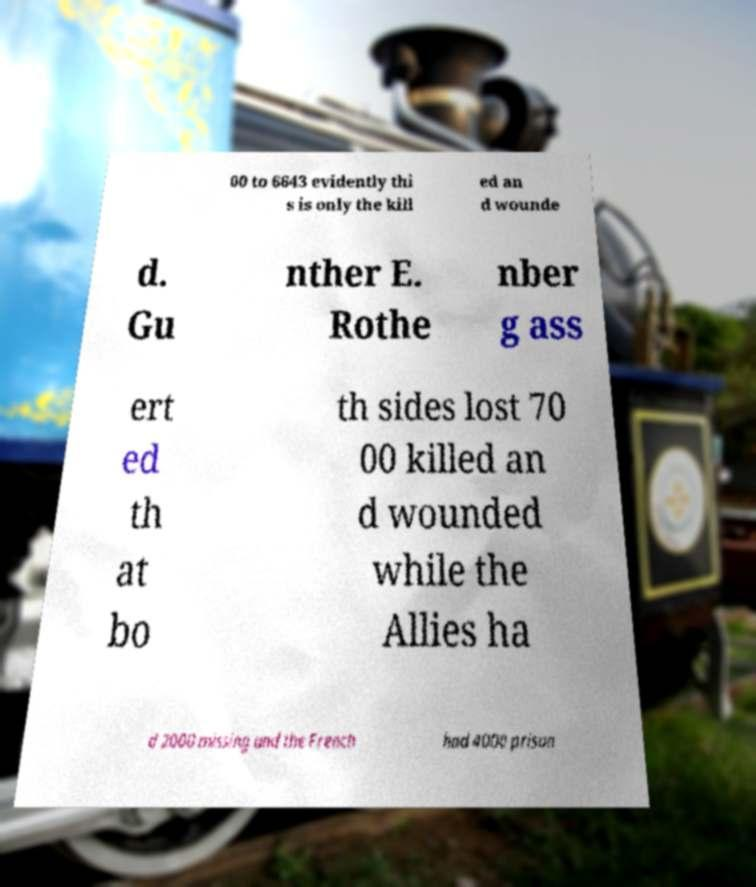Can you accurately transcribe the text from the provided image for me? 00 to 6643 evidently thi s is only the kill ed an d wounde d. Gu nther E. Rothe nber g ass ert ed th at bo th sides lost 70 00 killed an d wounded while the Allies ha d 2000 missing and the French had 4000 prison 